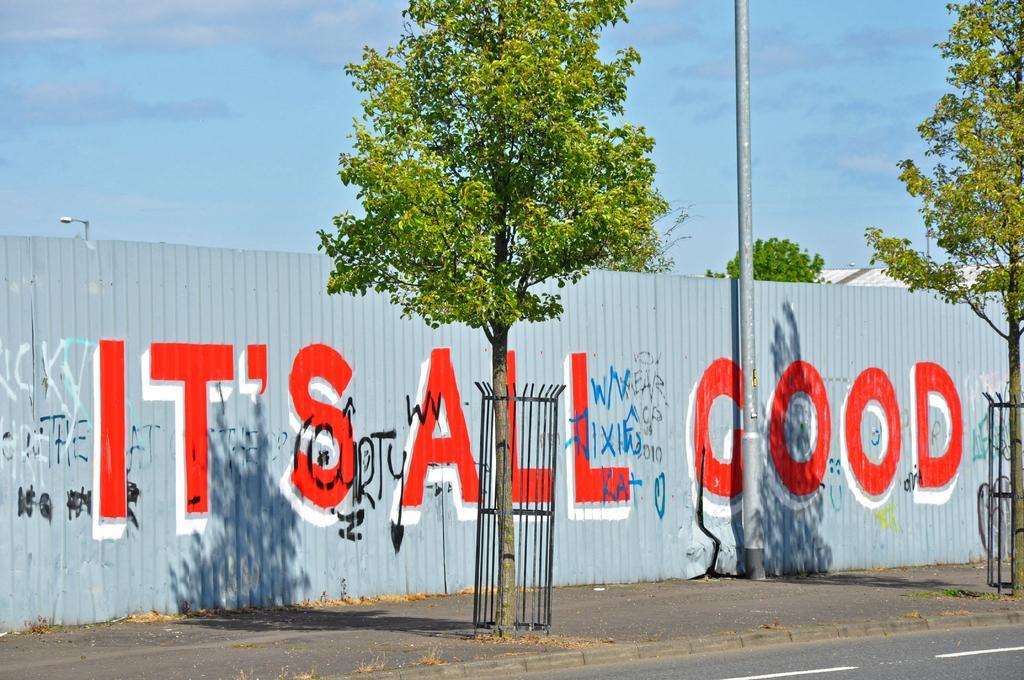In one or two sentences, can you explain what this image depicts? In the center of the image there is a tree in the fence on the road. On the right side of the image we can see tree. At the bottom there is a road. In the background we can see wall, pole, trees, buildings, sky and clouds. 